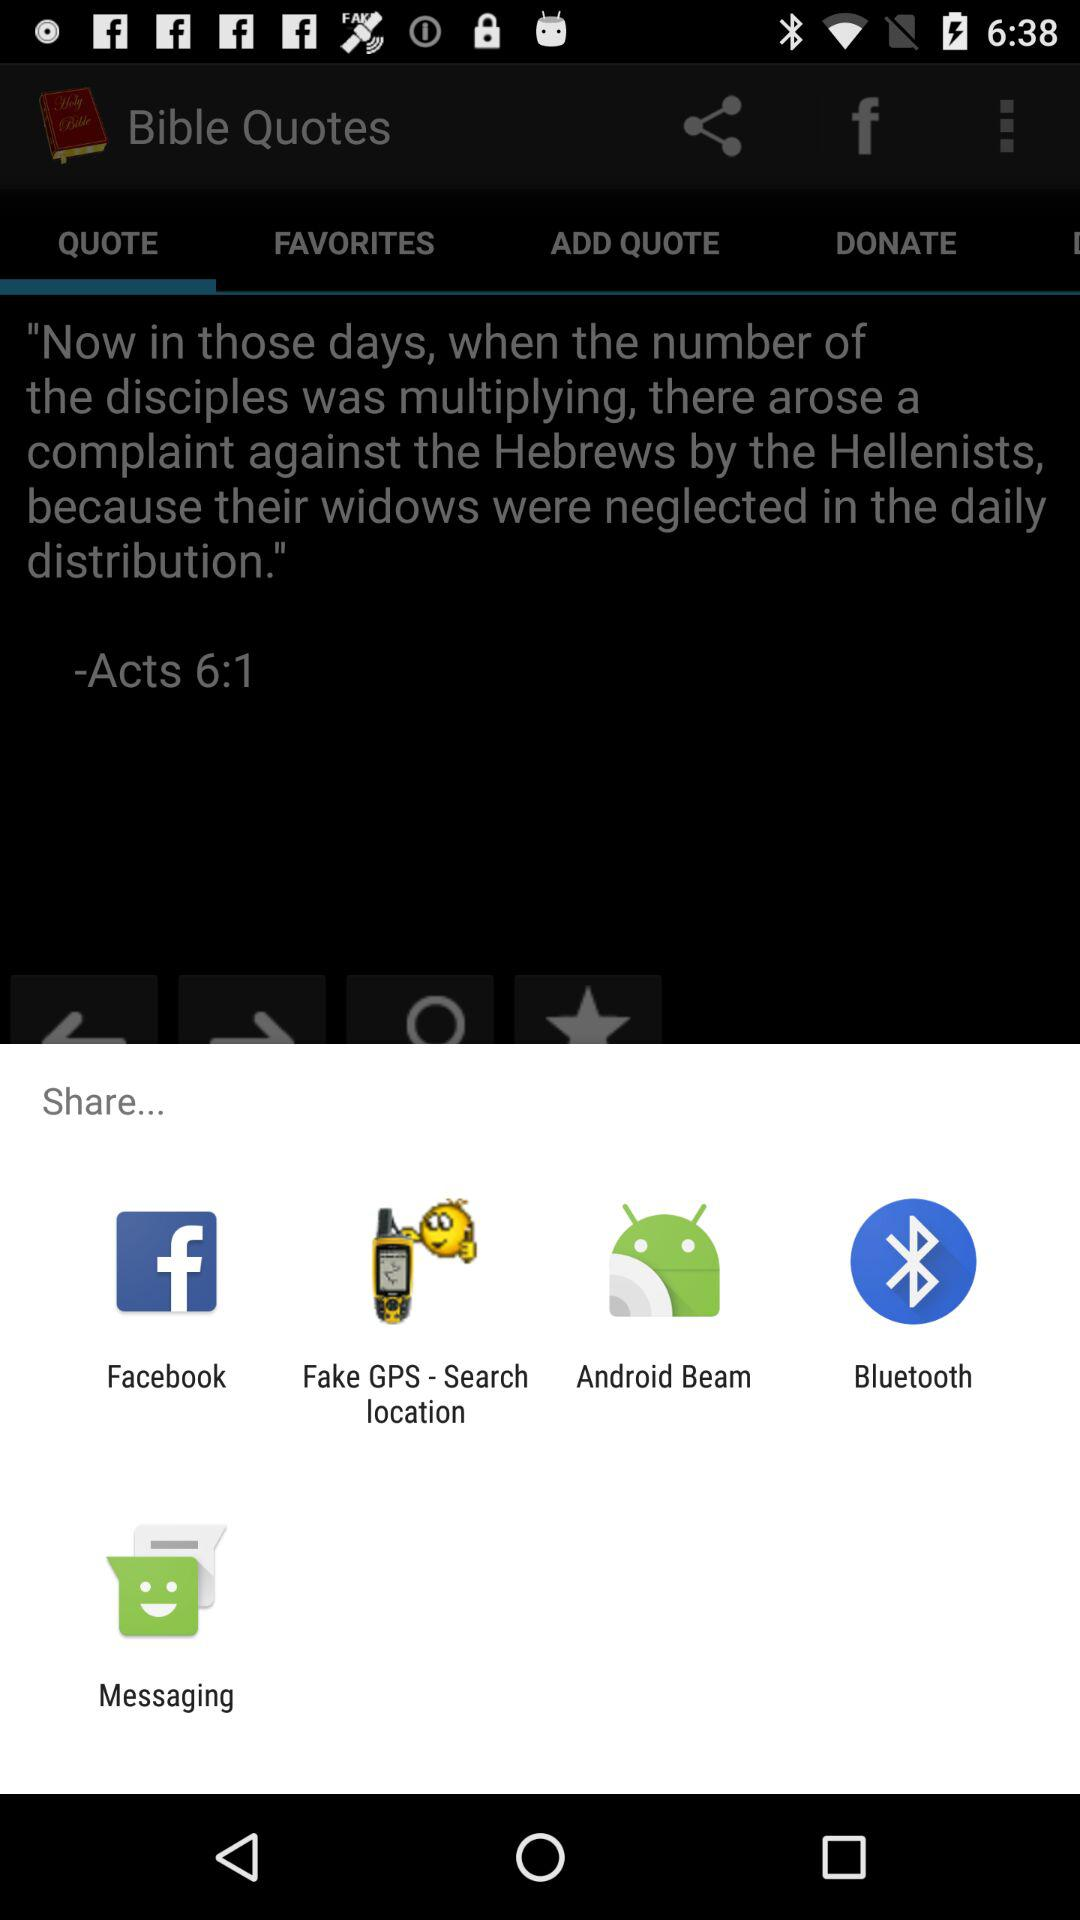Which options are given for sharing? The options are "Facebook", "Fake GPS - Search location", "Android Beam", "Bluetooth" and "Messaging". 